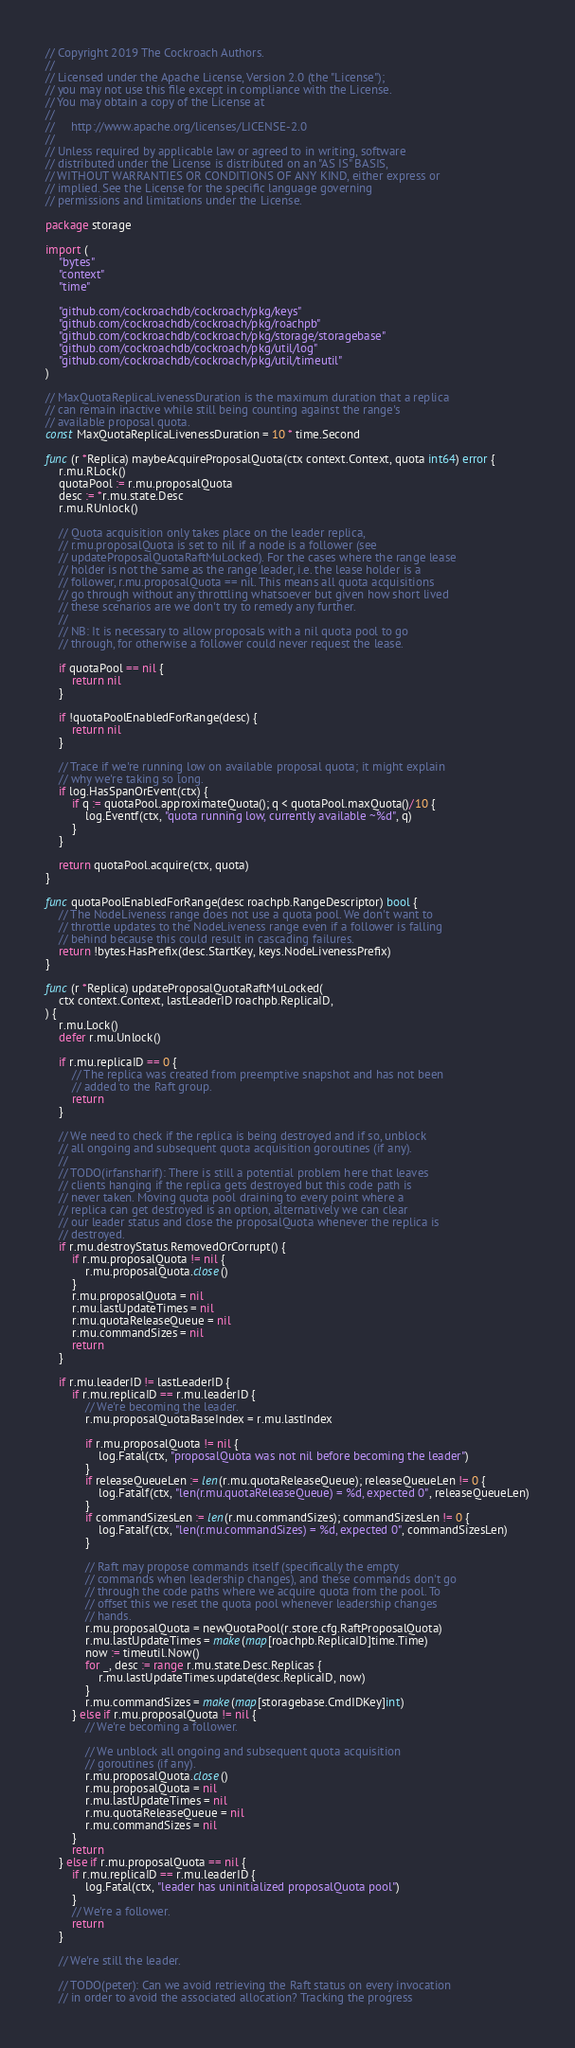Convert code to text. <code><loc_0><loc_0><loc_500><loc_500><_Go_>// Copyright 2019 The Cockroach Authors.
//
// Licensed under the Apache License, Version 2.0 (the "License");
// you may not use this file except in compliance with the License.
// You may obtain a copy of the License at
//
//     http://www.apache.org/licenses/LICENSE-2.0
//
// Unless required by applicable law or agreed to in writing, software
// distributed under the License is distributed on an "AS IS" BASIS,
// WITHOUT WARRANTIES OR CONDITIONS OF ANY KIND, either express or
// implied. See the License for the specific language governing
// permissions and limitations under the License.

package storage

import (
	"bytes"
	"context"
	"time"

	"github.com/cockroachdb/cockroach/pkg/keys"
	"github.com/cockroachdb/cockroach/pkg/roachpb"
	"github.com/cockroachdb/cockroach/pkg/storage/storagebase"
	"github.com/cockroachdb/cockroach/pkg/util/log"
	"github.com/cockroachdb/cockroach/pkg/util/timeutil"
)

// MaxQuotaReplicaLivenessDuration is the maximum duration that a replica
// can remain inactive while still being counting against the range's
// available proposal quota.
const MaxQuotaReplicaLivenessDuration = 10 * time.Second

func (r *Replica) maybeAcquireProposalQuota(ctx context.Context, quota int64) error {
	r.mu.RLock()
	quotaPool := r.mu.proposalQuota
	desc := *r.mu.state.Desc
	r.mu.RUnlock()

	// Quota acquisition only takes place on the leader replica,
	// r.mu.proposalQuota is set to nil if a node is a follower (see
	// updateProposalQuotaRaftMuLocked). For the cases where the range lease
	// holder is not the same as the range leader, i.e. the lease holder is a
	// follower, r.mu.proposalQuota == nil. This means all quota acquisitions
	// go through without any throttling whatsoever but given how short lived
	// these scenarios are we don't try to remedy any further.
	//
	// NB: It is necessary to allow proposals with a nil quota pool to go
	// through, for otherwise a follower could never request the lease.

	if quotaPool == nil {
		return nil
	}

	if !quotaPoolEnabledForRange(desc) {
		return nil
	}

	// Trace if we're running low on available proposal quota; it might explain
	// why we're taking so long.
	if log.HasSpanOrEvent(ctx) {
		if q := quotaPool.approximateQuota(); q < quotaPool.maxQuota()/10 {
			log.Eventf(ctx, "quota running low, currently available ~%d", q)
		}
	}

	return quotaPool.acquire(ctx, quota)
}

func quotaPoolEnabledForRange(desc roachpb.RangeDescriptor) bool {
	// The NodeLiveness range does not use a quota pool. We don't want to
	// throttle updates to the NodeLiveness range even if a follower is falling
	// behind because this could result in cascading failures.
	return !bytes.HasPrefix(desc.StartKey, keys.NodeLivenessPrefix)
}

func (r *Replica) updateProposalQuotaRaftMuLocked(
	ctx context.Context, lastLeaderID roachpb.ReplicaID,
) {
	r.mu.Lock()
	defer r.mu.Unlock()

	if r.mu.replicaID == 0 {
		// The replica was created from preemptive snapshot and has not been
		// added to the Raft group.
		return
	}

	// We need to check if the replica is being destroyed and if so, unblock
	// all ongoing and subsequent quota acquisition goroutines (if any).
	//
	// TODO(irfansharif): There is still a potential problem here that leaves
	// clients hanging if the replica gets destroyed but this code path is
	// never taken. Moving quota pool draining to every point where a
	// replica can get destroyed is an option, alternatively we can clear
	// our leader status and close the proposalQuota whenever the replica is
	// destroyed.
	if r.mu.destroyStatus.RemovedOrCorrupt() {
		if r.mu.proposalQuota != nil {
			r.mu.proposalQuota.close()
		}
		r.mu.proposalQuota = nil
		r.mu.lastUpdateTimes = nil
		r.mu.quotaReleaseQueue = nil
		r.mu.commandSizes = nil
		return
	}

	if r.mu.leaderID != lastLeaderID {
		if r.mu.replicaID == r.mu.leaderID {
			// We're becoming the leader.
			r.mu.proposalQuotaBaseIndex = r.mu.lastIndex

			if r.mu.proposalQuota != nil {
				log.Fatal(ctx, "proposalQuota was not nil before becoming the leader")
			}
			if releaseQueueLen := len(r.mu.quotaReleaseQueue); releaseQueueLen != 0 {
				log.Fatalf(ctx, "len(r.mu.quotaReleaseQueue) = %d, expected 0", releaseQueueLen)
			}
			if commandSizesLen := len(r.mu.commandSizes); commandSizesLen != 0 {
				log.Fatalf(ctx, "len(r.mu.commandSizes) = %d, expected 0", commandSizesLen)
			}

			// Raft may propose commands itself (specifically the empty
			// commands when leadership changes), and these commands don't go
			// through the code paths where we acquire quota from the pool. To
			// offset this we reset the quota pool whenever leadership changes
			// hands.
			r.mu.proposalQuota = newQuotaPool(r.store.cfg.RaftProposalQuota)
			r.mu.lastUpdateTimes = make(map[roachpb.ReplicaID]time.Time)
			now := timeutil.Now()
			for _, desc := range r.mu.state.Desc.Replicas {
				r.mu.lastUpdateTimes.update(desc.ReplicaID, now)
			}
			r.mu.commandSizes = make(map[storagebase.CmdIDKey]int)
		} else if r.mu.proposalQuota != nil {
			// We're becoming a follower.

			// We unblock all ongoing and subsequent quota acquisition
			// goroutines (if any).
			r.mu.proposalQuota.close()
			r.mu.proposalQuota = nil
			r.mu.lastUpdateTimes = nil
			r.mu.quotaReleaseQueue = nil
			r.mu.commandSizes = nil
		}
		return
	} else if r.mu.proposalQuota == nil {
		if r.mu.replicaID == r.mu.leaderID {
			log.Fatal(ctx, "leader has uninitialized proposalQuota pool")
		}
		// We're a follower.
		return
	}

	// We're still the leader.

	// TODO(peter): Can we avoid retrieving the Raft status on every invocation
	// in order to avoid the associated allocation? Tracking the progress</code> 